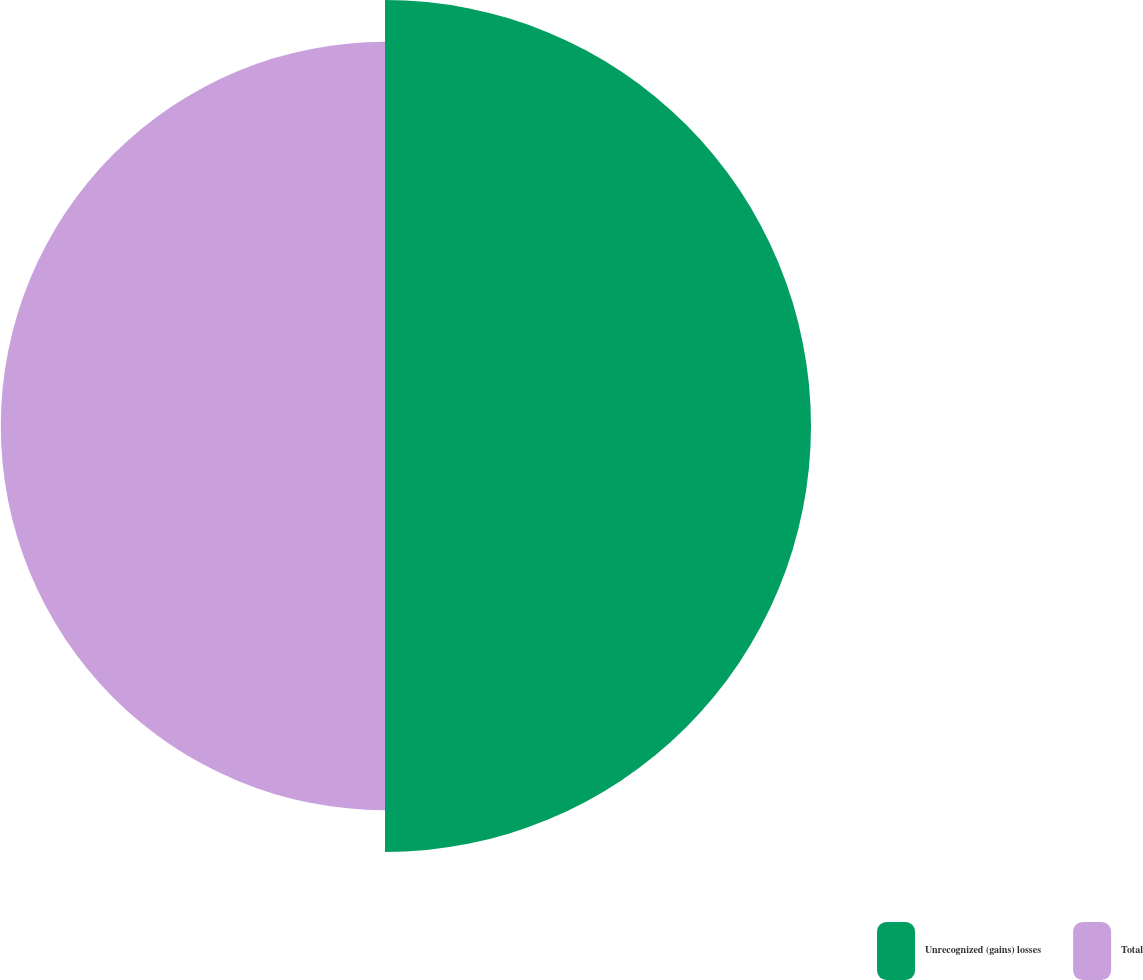Convert chart. <chart><loc_0><loc_0><loc_500><loc_500><pie_chart><fcel>Unrecognized (gains) losses<fcel>Total<nl><fcel>52.58%<fcel>47.42%<nl></chart> 